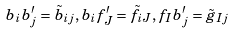Convert formula to latex. <formula><loc_0><loc_0><loc_500><loc_500>b _ { i } b _ { j } ^ { \prime } = \tilde { b } _ { i j } , b _ { i } f _ { J } ^ { \prime } = \tilde { f } _ { i J } , f _ { I } b _ { j } ^ { \prime } = \tilde { g } _ { I j }</formula> 